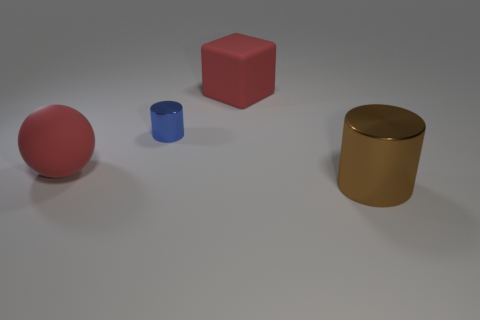Add 3 tiny brown things. How many objects exist? 7 Subtract all spheres. How many objects are left? 3 Subtract all brown cylinders. Subtract all brown things. How many objects are left? 2 Add 2 big blocks. How many big blocks are left? 3 Add 2 red matte things. How many red matte things exist? 4 Subtract 0 purple blocks. How many objects are left? 4 